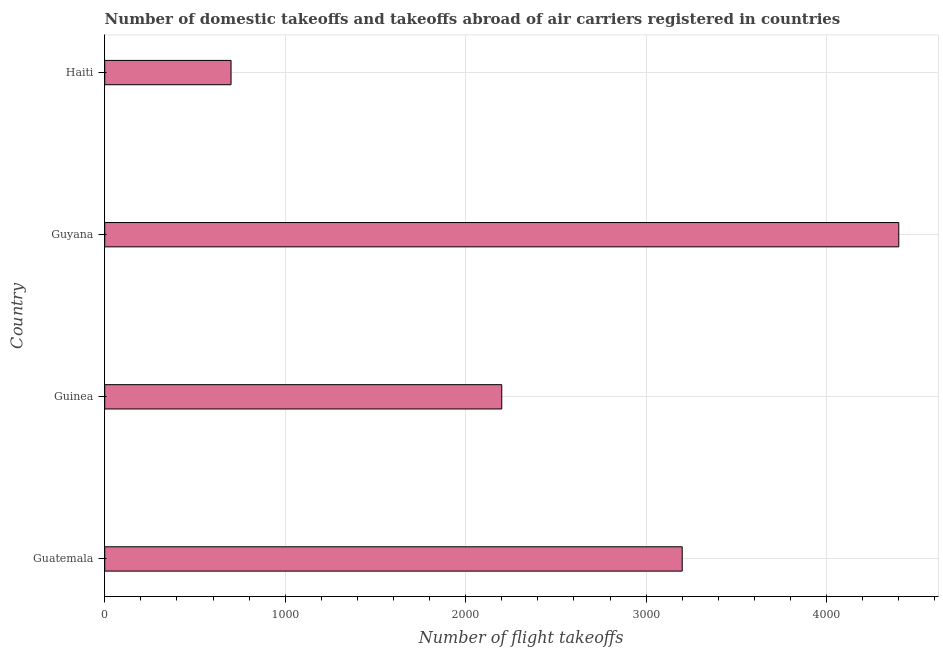Does the graph contain any zero values?
Offer a terse response. No. Does the graph contain grids?
Offer a terse response. Yes. What is the title of the graph?
Make the answer very short. Number of domestic takeoffs and takeoffs abroad of air carriers registered in countries. What is the label or title of the X-axis?
Your response must be concise. Number of flight takeoffs. What is the number of flight takeoffs in Guatemala?
Provide a short and direct response. 3200. Across all countries, what is the maximum number of flight takeoffs?
Your response must be concise. 4400. Across all countries, what is the minimum number of flight takeoffs?
Give a very brief answer. 700. In which country was the number of flight takeoffs maximum?
Your response must be concise. Guyana. In which country was the number of flight takeoffs minimum?
Provide a short and direct response. Haiti. What is the sum of the number of flight takeoffs?
Ensure brevity in your answer.  1.05e+04. What is the difference between the number of flight takeoffs in Guatemala and Haiti?
Offer a terse response. 2500. What is the average number of flight takeoffs per country?
Offer a terse response. 2625. What is the median number of flight takeoffs?
Your answer should be very brief. 2700. Is the number of flight takeoffs in Guinea less than that in Haiti?
Offer a very short reply. No. What is the difference between the highest and the second highest number of flight takeoffs?
Your answer should be very brief. 1200. Is the sum of the number of flight takeoffs in Guyana and Haiti greater than the maximum number of flight takeoffs across all countries?
Make the answer very short. Yes. What is the difference between the highest and the lowest number of flight takeoffs?
Your answer should be very brief. 3700. In how many countries, is the number of flight takeoffs greater than the average number of flight takeoffs taken over all countries?
Your answer should be very brief. 2. How many countries are there in the graph?
Your answer should be compact. 4. Are the values on the major ticks of X-axis written in scientific E-notation?
Offer a terse response. No. What is the Number of flight takeoffs of Guatemala?
Offer a terse response. 3200. What is the Number of flight takeoffs of Guinea?
Your response must be concise. 2200. What is the Number of flight takeoffs of Guyana?
Your answer should be compact. 4400. What is the Number of flight takeoffs of Haiti?
Provide a succinct answer. 700. What is the difference between the Number of flight takeoffs in Guatemala and Guyana?
Keep it short and to the point. -1200. What is the difference between the Number of flight takeoffs in Guatemala and Haiti?
Your answer should be compact. 2500. What is the difference between the Number of flight takeoffs in Guinea and Guyana?
Give a very brief answer. -2200. What is the difference between the Number of flight takeoffs in Guinea and Haiti?
Ensure brevity in your answer.  1500. What is the difference between the Number of flight takeoffs in Guyana and Haiti?
Provide a succinct answer. 3700. What is the ratio of the Number of flight takeoffs in Guatemala to that in Guinea?
Provide a succinct answer. 1.46. What is the ratio of the Number of flight takeoffs in Guatemala to that in Guyana?
Keep it short and to the point. 0.73. What is the ratio of the Number of flight takeoffs in Guatemala to that in Haiti?
Offer a very short reply. 4.57. What is the ratio of the Number of flight takeoffs in Guinea to that in Haiti?
Your response must be concise. 3.14. What is the ratio of the Number of flight takeoffs in Guyana to that in Haiti?
Your response must be concise. 6.29. 